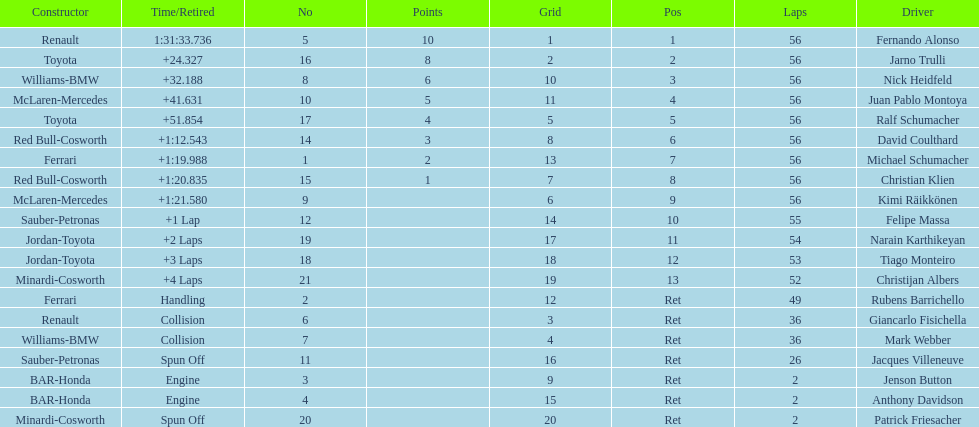How long did it take fernando alonso to finish the race? 1:31:33.736. 